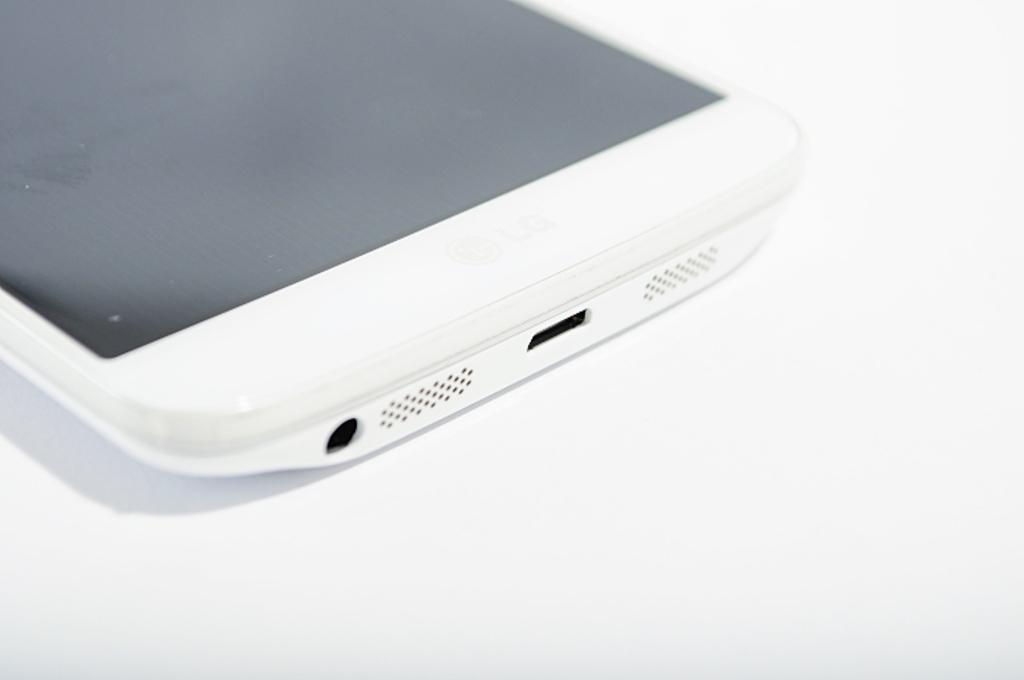How would you summarize this image in a sentence or two? This image consists of a mobile in white color. The background is white in color. 